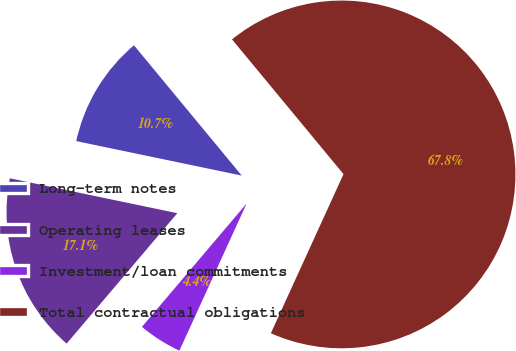Convert chart. <chart><loc_0><loc_0><loc_500><loc_500><pie_chart><fcel>Long-term notes<fcel>Operating leases<fcel>Investment/loan commitments<fcel>Total contractual obligations<nl><fcel>10.73%<fcel>17.07%<fcel>4.38%<fcel>67.82%<nl></chart> 